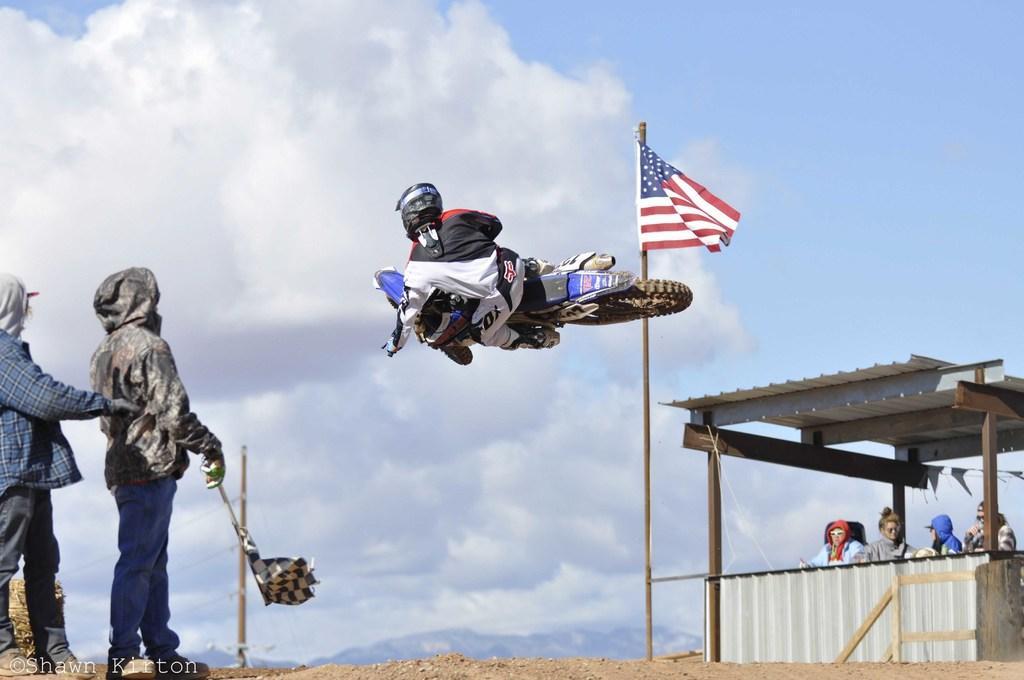In one or two sentences, can you explain what this image depicts? In the middle there is a man he is riding motorbike. On the right there are four people sitting on the chairs. On the left there are two people staring at motorbike. In the middle there is a flag and pole. In the background there is sky ,hill and clouds. 